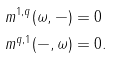Convert formula to latex. <formula><loc_0><loc_0><loc_500><loc_500>m ^ { 1 , q } ( \omega , - ) & = 0 \\ m ^ { q , 1 } ( - , \omega ) & = 0 .</formula> 